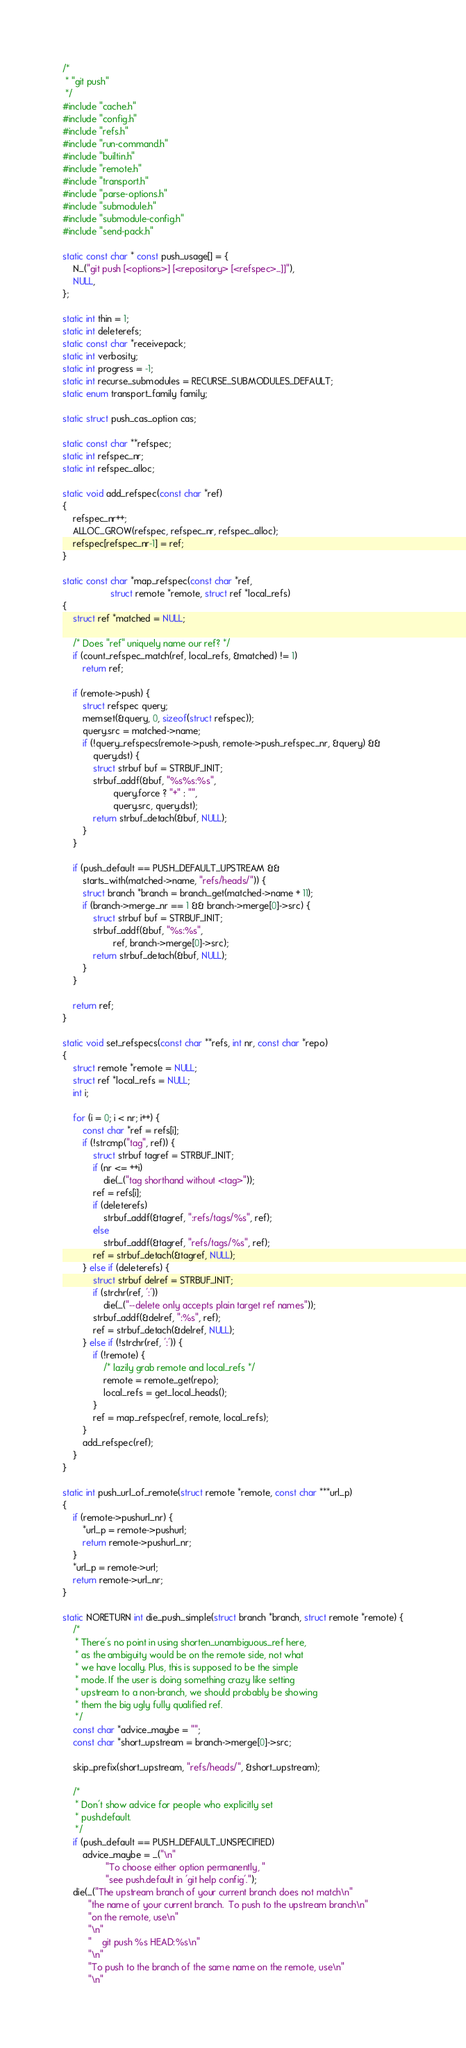<code> <loc_0><loc_0><loc_500><loc_500><_C_>/*
 * "git push"
 */
#include "cache.h"
#include "config.h"
#include "refs.h"
#include "run-command.h"
#include "builtin.h"
#include "remote.h"
#include "transport.h"
#include "parse-options.h"
#include "submodule.h"
#include "submodule-config.h"
#include "send-pack.h"

static const char * const push_usage[] = {
	N_("git push [<options>] [<repository> [<refspec>...]]"),
	NULL,
};

static int thin = 1;
static int deleterefs;
static const char *receivepack;
static int verbosity;
static int progress = -1;
static int recurse_submodules = RECURSE_SUBMODULES_DEFAULT;
static enum transport_family family;

static struct push_cas_option cas;

static const char **refspec;
static int refspec_nr;
static int refspec_alloc;

static void add_refspec(const char *ref)
{
	refspec_nr++;
	ALLOC_GROW(refspec, refspec_nr, refspec_alloc);
	refspec[refspec_nr-1] = ref;
}

static const char *map_refspec(const char *ref,
			       struct remote *remote, struct ref *local_refs)
{
	struct ref *matched = NULL;

	/* Does "ref" uniquely name our ref? */
	if (count_refspec_match(ref, local_refs, &matched) != 1)
		return ref;

	if (remote->push) {
		struct refspec query;
		memset(&query, 0, sizeof(struct refspec));
		query.src = matched->name;
		if (!query_refspecs(remote->push, remote->push_refspec_nr, &query) &&
		    query.dst) {
			struct strbuf buf = STRBUF_INIT;
			strbuf_addf(&buf, "%s%s:%s",
				    query.force ? "+" : "",
				    query.src, query.dst);
			return strbuf_detach(&buf, NULL);
		}
	}

	if (push_default == PUSH_DEFAULT_UPSTREAM &&
	    starts_with(matched->name, "refs/heads/")) {
		struct branch *branch = branch_get(matched->name + 11);
		if (branch->merge_nr == 1 && branch->merge[0]->src) {
			struct strbuf buf = STRBUF_INIT;
			strbuf_addf(&buf, "%s:%s",
				    ref, branch->merge[0]->src);
			return strbuf_detach(&buf, NULL);
		}
	}

	return ref;
}

static void set_refspecs(const char **refs, int nr, const char *repo)
{
	struct remote *remote = NULL;
	struct ref *local_refs = NULL;
	int i;

	for (i = 0; i < nr; i++) {
		const char *ref = refs[i];
		if (!strcmp("tag", ref)) {
			struct strbuf tagref = STRBUF_INIT;
			if (nr <= ++i)
				die(_("tag shorthand without <tag>"));
			ref = refs[i];
			if (deleterefs)
				strbuf_addf(&tagref, ":refs/tags/%s", ref);
			else
				strbuf_addf(&tagref, "refs/tags/%s", ref);
			ref = strbuf_detach(&tagref, NULL);
		} else if (deleterefs) {
			struct strbuf delref = STRBUF_INIT;
			if (strchr(ref, ':'))
				die(_("--delete only accepts plain target ref names"));
			strbuf_addf(&delref, ":%s", ref);
			ref = strbuf_detach(&delref, NULL);
		} else if (!strchr(ref, ':')) {
			if (!remote) {
				/* lazily grab remote and local_refs */
				remote = remote_get(repo);
				local_refs = get_local_heads();
			}
			ref = map_refspec(ref, remote, local_refs);
		}
		add_refspec(ref);
	}
}

static int push_url_of_remote(struct remote *remote, const char ***url_p)
{
	if (remote->pushurl_nr) {
		*url_p = remote->pushurl;
		return remote->pushurl_nr;
	}
	*url_p = remote->url;
	return remote->url_nr;
}

static NORETURN int die_push_simple(struct branch *branch, struct remote *remote) {
	/*
	 * There's no point in using shorten_unambiguous_ref here,
	 * as the ambiguity would be on the remote side, not what
	 * we have locally. Plus, this is supposed to be the simple
	 * mode. If the user is doing something crazy like setting
	 * upstream to a non-branch, we should probably be showing
	 * them the big ugly fully qualified ref.
	 */
	const char *advice_maybe = "";
	const char *short_upstream = branch->merge[0]->src;

	skip_prefix(short_upstream, "refs/heads/", &short_upstream);

	/*
	 * Don't show advice for people who explicitly set
	 * push.default.
	 */
	if (push_default == PUSH_DEFAULT_UNSPECIFIED)
		advice_maybe = _("\n"
				 "To choose either option permanently, "
				 "see push.default in 'git help config'.");
	die(_("The upstream branch of your current branch does not match\n"
	      "the name of your current branch.  To push to the upstream branch\n"
	      "on the remote, use\n"
	      "\n"
	      "    git push %s HEAD:%s\n"
	      "\n"
	      "To push to the branch of the same name on the remote, use\n"
	      "\n"</code> 